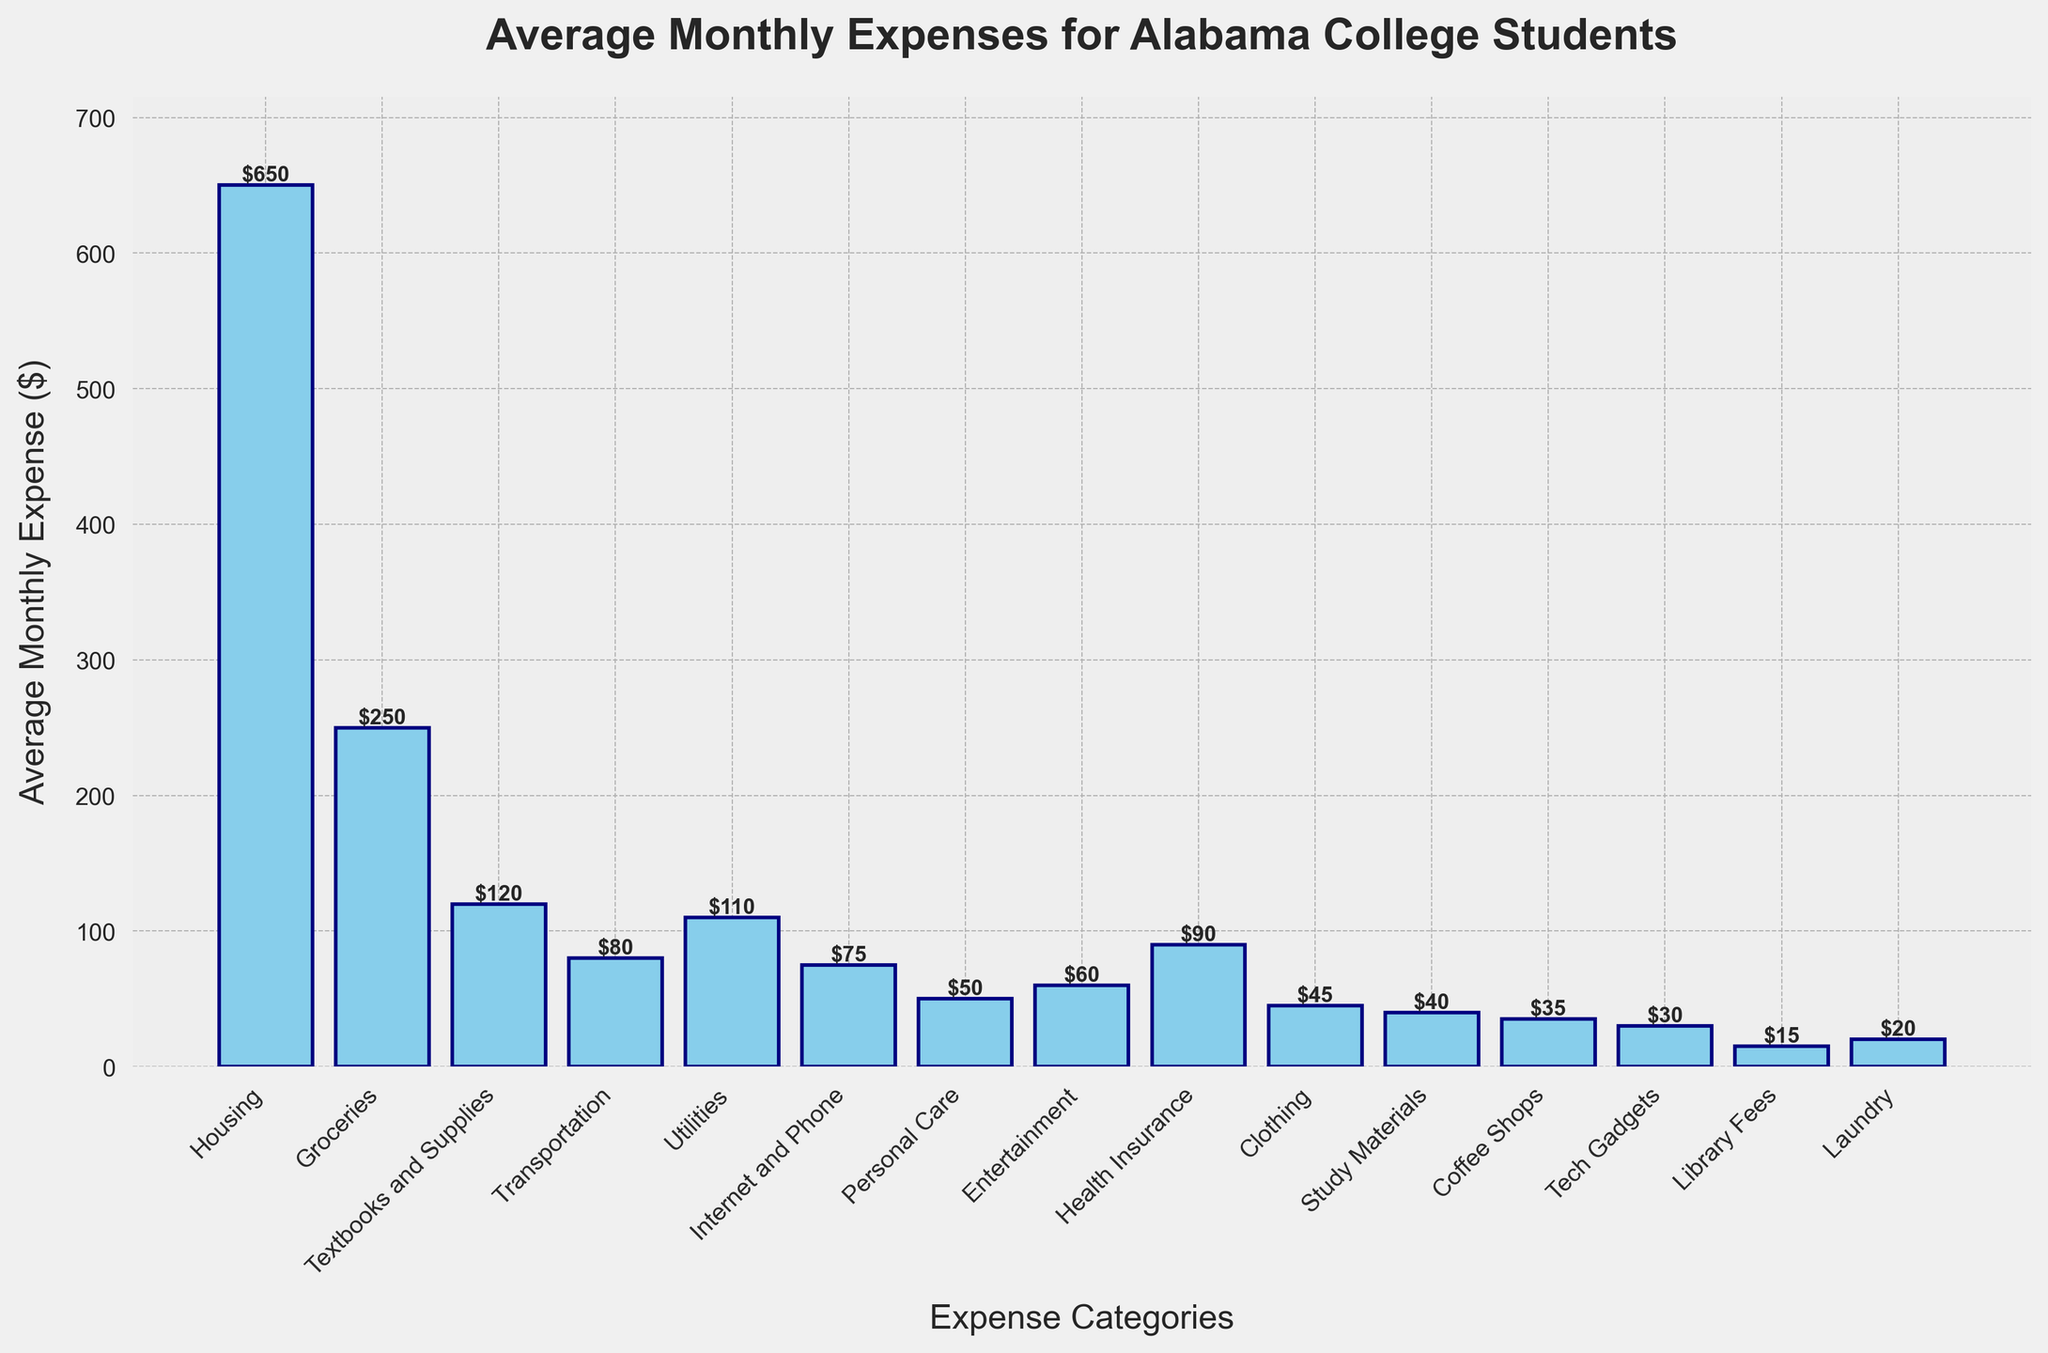Which category has the highest average monthly expense? By looking at the heights of the bars, the tallest bar represents the highest average monthly expense. The Housing category has the tallest bar.
Answer: Housing What is the total average monthly expense for Textbooks and Supplies, Transportation, and Utilities? To calculate the total, add the average monthly expenses of these categories: 120 (Textbooks and Supplies) + 80 (Transportation) + 110 (Utilities) = 310
Answer: 310 How does the average monthly expense for Groceries compare to that for Internet and Phone? Compare the heights of the bars for Groceries and Internet and Phone. The Groceries bar is higher than the Internet and Phone bar.
Answer: Groceries is higher Which category has the lowest average monthly expense, and what is the value? Look for the shortest bar on the chart, which corresponds to the Library Fees category. The value is at the top of the bar.
Answer: Library Fees, $15 What is the difference between the average monthly expenses of the highest and the lowest categories? The highest category is Housing with $650, and the lowest is Library Fees with $15. Subtract the Library Fees value from the Housing value: 650 - 15 = 635
Answer: 635 What is the combined average monthly expense of Personal Care, Entertainment, and Coffee Shops? Sum the average monthly expenses for these categories: 50 (Personal Care) + 60 (Entertainment) + 35 (Coffee Shops) = 145
Answer: 145 Which two categories have the closest average monthly expenses? Compare the heights of the bars and look for those that are closest in value. Clothing is $45, and Study Materials is $40, making them the closest.
Answer: Clothing and Study Materials How many categories have an average monthly expense greater than $100? Count the bars with heights above the $100 mark: Housing, Groceries, Textbooks and Supplies, Utilities, and Health Insurance. There are 5 categories.
Answer: 5 What is the sum of average monthly expenses for all categories related to education (Textbooks and Supplies, Study Materials, Library Fees)? Sum the average monthly expenses of these categories: 120 (Textbooks and Supplies) + 40 (Study Materials) + 15 (Library Fees) = 175
Answer: 175 Which category has a higher average monthly expense: Health Insurance or Transportation? Compare the heights of the Health Insurance and Transportation bars. The Health Insurance bar is taller, indicating a higher expense.
Answer: Health Insurance 